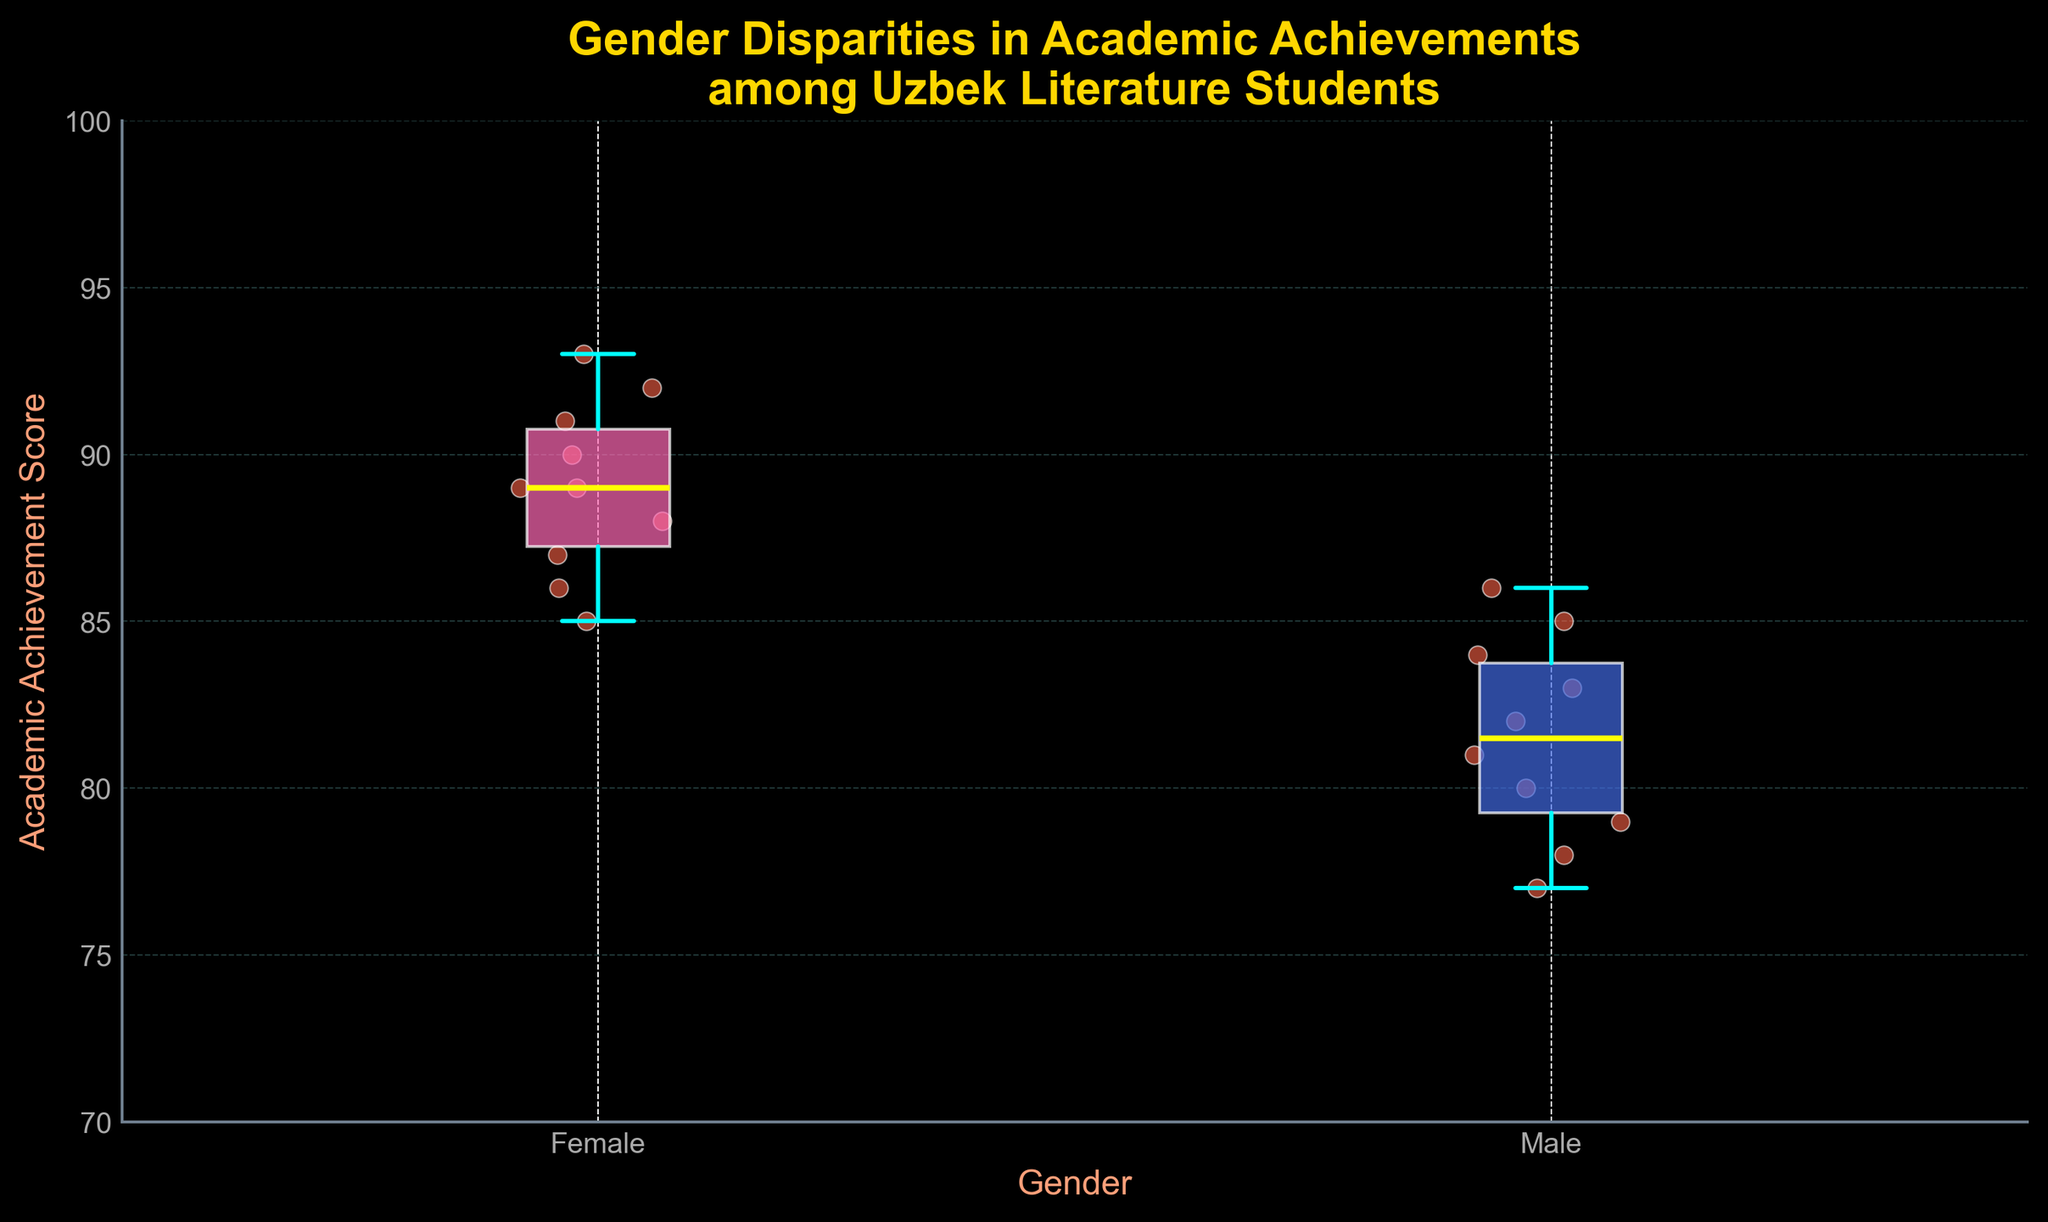What's the title of the figure? The title is the text found at the top of the figure. It describes what the figure is about.
Answer: Gender Disparities in Academic Achievements among Uzbek Literature Students What is the range of academic achievement scores for male students based on the box plot? The range of academic achievement scores is the difference between the maximum and minimum values displayed by the whiskers of the box plot for male students. The whiskers represent the extremes.
Answer: 77 to 86 What is the median academic achievement score for female students? The median is represented by the yellow line within the box for female students.
Answer: 89 Which gender has a higher lower quartile (Q1) in academic achievement? The lower quartile (Q1) is represented by the bottom edge of the box. Comparing these edges between the two genders allows us to determine which one is higher.
Answer: Female What is the interquartile range (IQR) for female students? The IQR is the difference between the upper (Q3) and lower (Q1) quartiles for female students. These are the top and bottom edges of the box, respectively.
Answer: 6.5 Compare the variability in academic achievements between male and female students. The variability can be observed by comparing the heights of the boxes and whiskers. Larger boxes or whiskers indicate higher variability.
Answer: Male students have higher variability Between male and female students, which group has the highest individual academic achievement score, and what is that score? The highest individual score is represented by the top whisker or any outlier dot above it. Compare these points for both genders.
Answer: Female, 93 What color represents the boxes for female and male students? The color of the boxes distinguishes between the two genders. Look at the colors used for the boxes in the plot.
Answer: Female: Pink, Male: Blue Are there any outliers in the academic achievement scores for male students? Outliers, if any, are represented by dots outside the whiskers of the box plot. Check for any such dots in the male students' box plot.
Answer: No What is the median value for male students? The median is the yellow line in the center of the box plot representing male students.
Answer: 82 